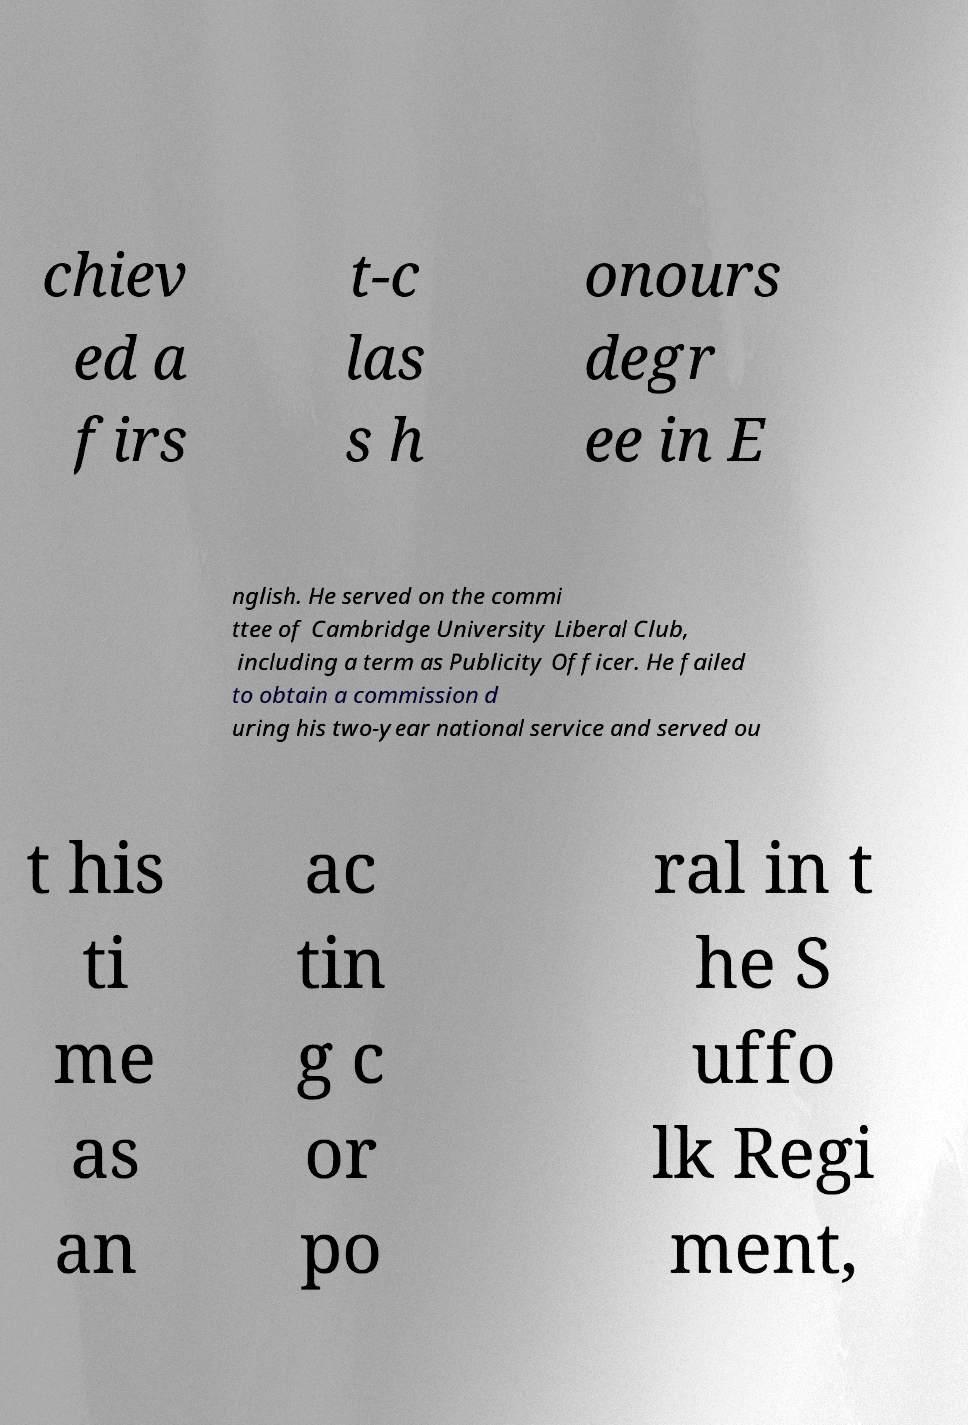There's text embedded in this image that I need extracted. Can you transcribe it verbatim? chiev ed a firs t-c las s h onours degr ee in E nglish. He served on the commi ttee of Cambridge University Liberal Club, including a term as Publicity Officer. He failed to obtain a commission d uring his two-year national service and served ou t his ti me as an ac tin g c or po ral in t he S uffo lk Regi ment, 